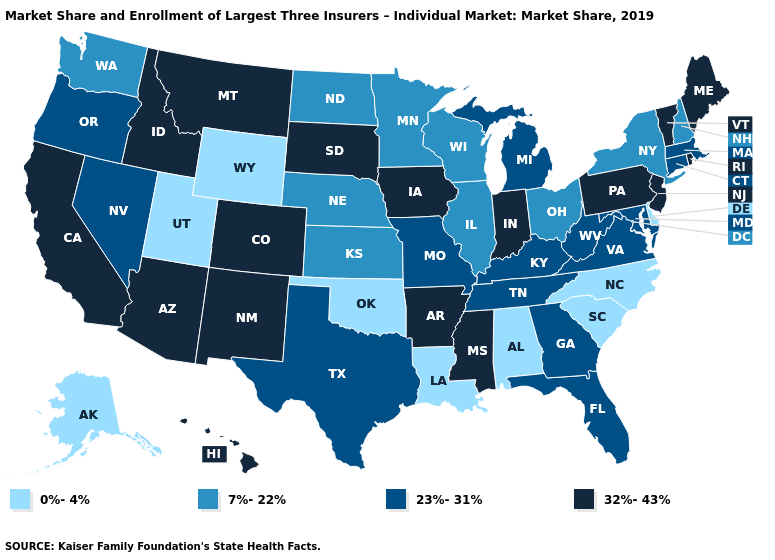What is the highest value in states that border California?
Quick response, please. 32%-43%. What is the highest value in the USA?
Short answer required. 32%-43%. How many symbols are there in the legend?
Keep it brief. 4. What is the lowest value in states that border Indiana?
Be succinct. 7%-22%. Name the states that have a value in the range 7%-22%?
Concise answer only. Illinois, Kansas, Minnesota, Nebraska, New Hampshire, New York, North Dakota, Ohio, Washington, Wisconsin. What is the value of Iowa?
Quick response, please. 32%-43%. Which states have the highest value in the USA?
Keep it brief. Arizona, Arkansas, California, Colorado, Hawaii, Idaho, Indiana, Iowa, Maine, Mississippi, Montana, New Jersey, New Mexico, Pennsylvania, Rhode Island, South Dakota, Vermont. Which states hav the highest value in the West?
Give a very brief answer. Arizona, California, Colorado, Hawaii, Idaho, Montana, New Mexico. Does Arkansas have the highest value in the South?
Be succinct. Yes. How many symbols are there in the legend?
Give a very brief answer. 4. What is the highest value in states that border Wisconsin?
Write a very short answer. 32%-43%. Does New York have a higher value than Alaska?
Short answer required. Yes. What is the value of Maine?
Give a very brief answer. 32%-43%. What is the value of Texas?
Short answer required. 23%-31%. What is the lowest value in the West?
Quick response, please. 0%-4%. 